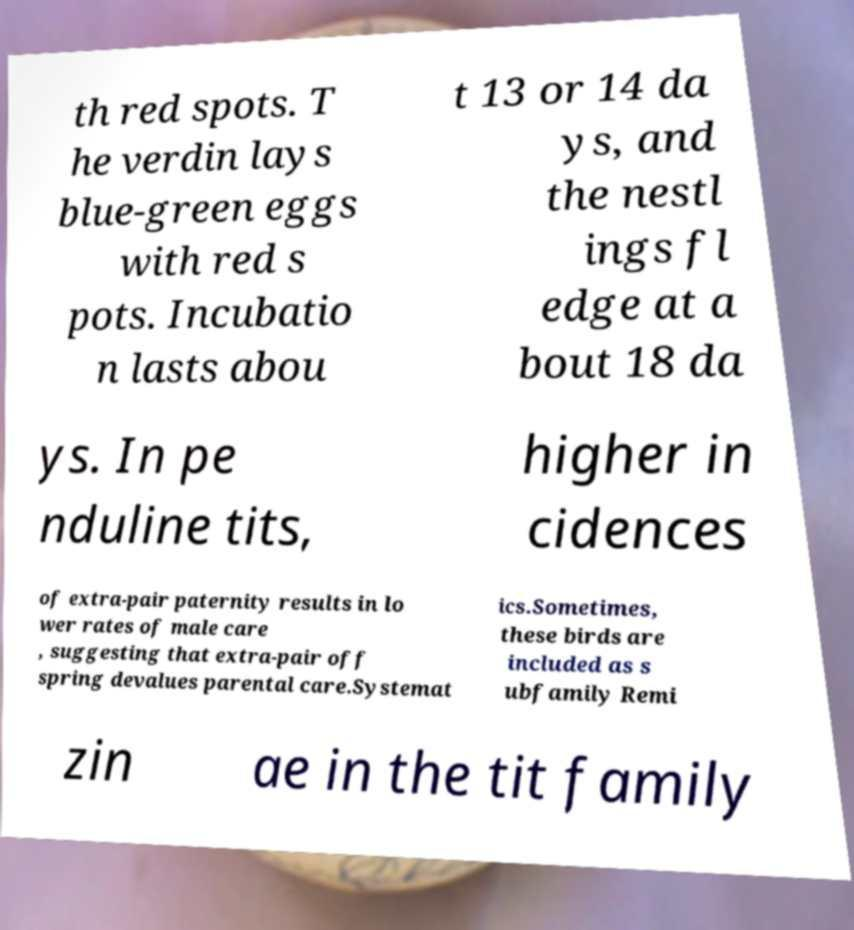Please read and relay the text visible in this image. What does it say? th red spots. T he verdin lays blue-green eggs with red s pots. Incubatio n lasts abou t 13 or 14 da ys, and the nestl ings fl edge at a bout 18 da ys. In pe nduline tits, higher in cidences of extra-pair paternity results in lo wer rates of male care , suggesting that extra-pair off spring devalues parental care.Systemat ics.Sometimes, these birds are included as s ubfamily Remi zin ae in the tit family 